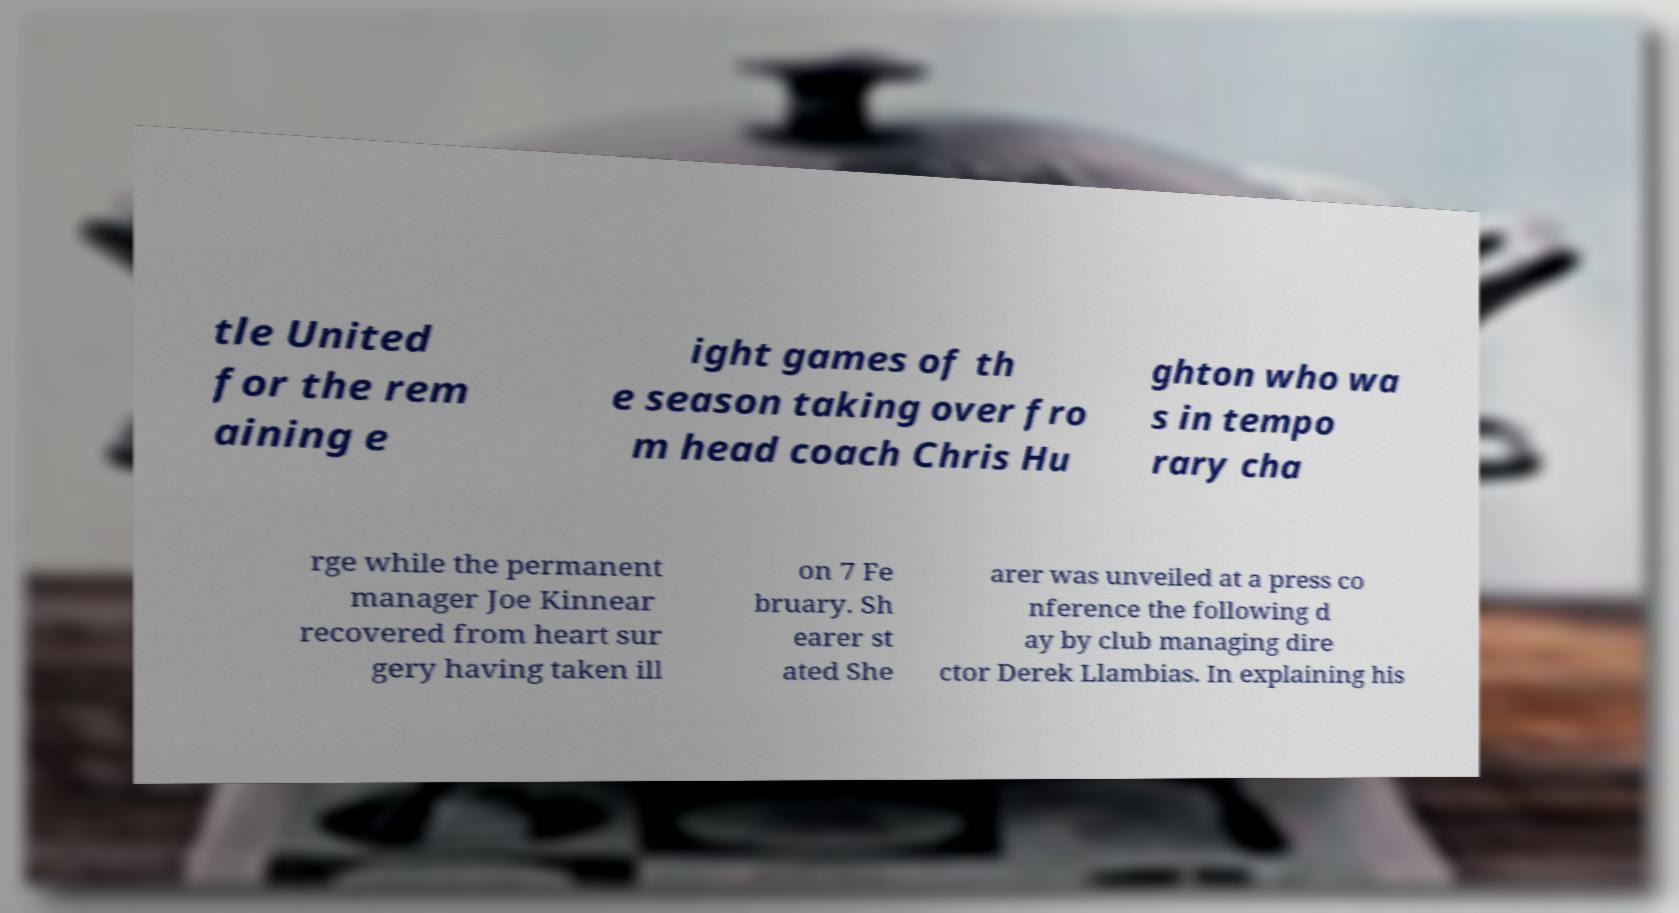Please read and relay the text visible in this image. What does it say? tle United for the rem aining e ight games of th e season taking over fro m head coach Chris Hu ghton who wa s in tempo rary cha rge while the permanent manager Joe Kinnear recovered from heart sur gery having taken ill on 7 Fe bruary. Sh earer st ated She arer was unveiled at a press co nference the following d ay by club managing dire ctor Derek Llambias. In explaining his 